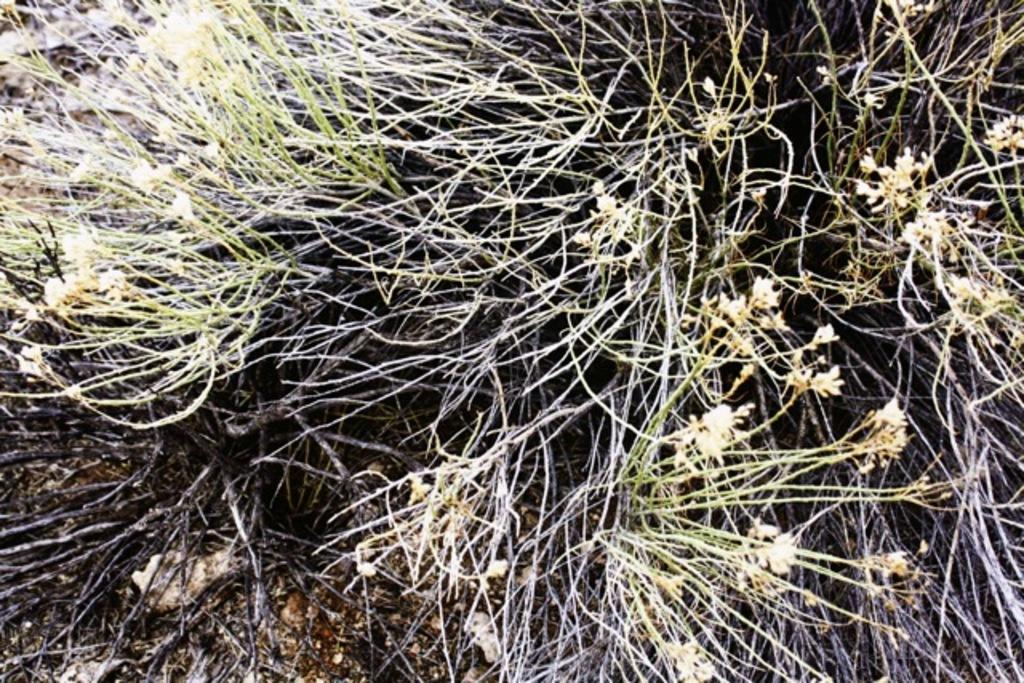What type of vegetation can be seen in the image? There are flowers on the plants in the image. What is present at the bottom of the image? There is mud at the bottom of the image. What type of inorganic material can be seen in the image? There are stones in the image. What type of goose can be seen in the image? There is no goose present in the image. What time of day is depicted in the image? The time of day is not mentioned in the provided facts, so it cannot be determined from the image. 